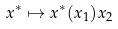Convert formula to latex. <formula><loc_0><loc_0><loc_500><loc_500>x ^ { * } \mapsto x ^ { * } ( x _ { 1 } ) x _ { 2 }</formula> 